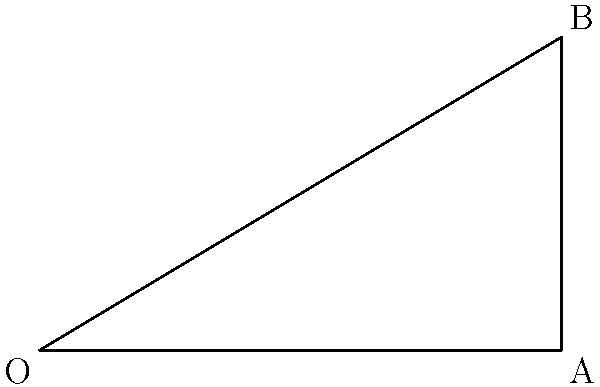As a sports camp organizer working with long jump coaches, you're tasked with explaining the optimal angle for a long jump. Given that the initial velocity of a jumper is $v_0 = 10$ m/s, and neglecting air resistance, what is the optimal angle $\theta$ for achieving the maximum horizontal distance? Use the diagram and trigonometric principles to support your answer. To find the optimal angle for a long jump, we need to consider the projectile motion equations and maximize the horizontal distance. Here's the step-by-step process:

1) The horizontal distance (d) in projectile motion is given by:
   $$d = \frac{v_0^2 \sin(2\theta)}{g}$$
   where $v_0$ is the initial velocity, $\theta$ is the launch angle, and $g$ is the acceleration due to gravity (9.8 m/s²).

2) To maximize d, we need to maximize $\sin(2\theta)$.

3) The maximum value of sine is 1, which occurs when its argument is 90°.

4) Therefore, $2\theta = 90°$

5) Solving for $\theta$:
   $$\theta = 45°$$

6) This result is consistent with the principle that, in the absence of air resistance, the optimal launch angle for maximum range is always 45°.

7) We can verify this by calculating the distance for different angles:
   At 45°: $d = \frac{10^2 \sin(2(45°))}{9.8} = 10.2$ m
   At 40°: $d = \frac{10^2 \sin(2(40°))}{9.8} = 10.1$ m
   At 50°: $d = \frac{10^2 \sin(2(50°))}{9.8} = 10.1$ m

This demonstrates that 45° indeed gives the maximum distance.
Answer: 45° 